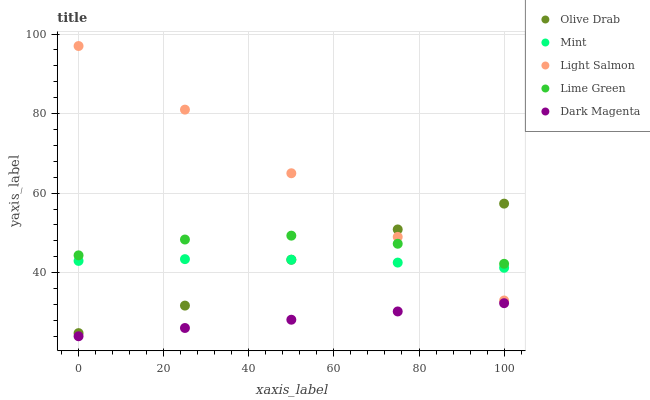Does Dark Magenta have the minimum area under the curve?
Answer yes or no. Yes. Does Light Salmon have the maximum area under the curve?
Answer yes or no. Yes. Does Mint have the minimum area under the curve?
Answer yes or no. No. Does Mint have the maximum area under the curve?
Answer yes or no. No. Is Light Salmon the smoothest?
Answer yes or no. Yes. Is Olive Drab the roughest?
Answer yes or no. Yes. Is Mint the smoothest?
Answer yes or no. No. Is Mint the roughest?
Answer yes or no. No. Does Dark Magenta have the lowest value?
Answer yes or no. Yes. Does Light Salmon have the lowest value?
Answer yes or no. No. Does Light Salmon have the highest value?
Answer yes or no. Yes. Does Mint have the highest value?
Answer yes or no. No. Is Dark Magenta less than Mint?
Answer yes or no. Yes. Is Mint greater than Dark Magenta?
Answer yes or no. Yes. Does Lime Green intersect Olive Drab?
Answer yes or no. Yes. Is Lime Green less than Olive Drab?
Answer yes or no. No. Is Lime Green greater than Olive Drab?
Answer yes or no. No. Does Dark Magenta intersect Mint?
Answer yes or no. No. 